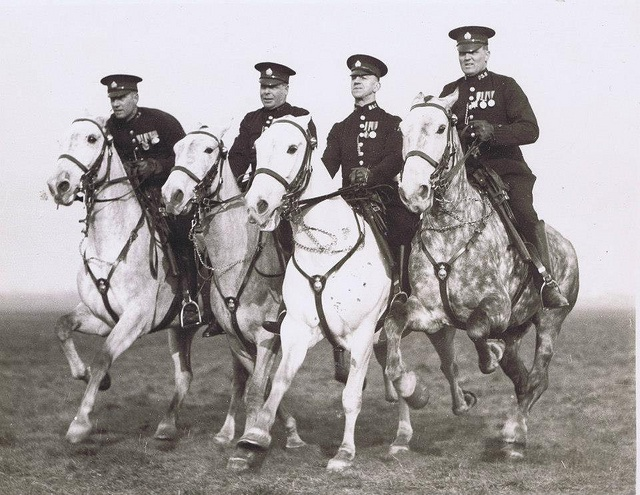Describe the objects in this image and their specific colors. I can see horse in lavender, gray, darkgray, lightgray, and black tones, horse in lavender, lightgray, gray, darkgray, and black tones, horse in lavender, lightgray, gray, darkgray, and black tones, horse in lavender, gray, darkgray, lightgray, and black tones, and people in lavender, gray, black, and lightgray tones in this image. 